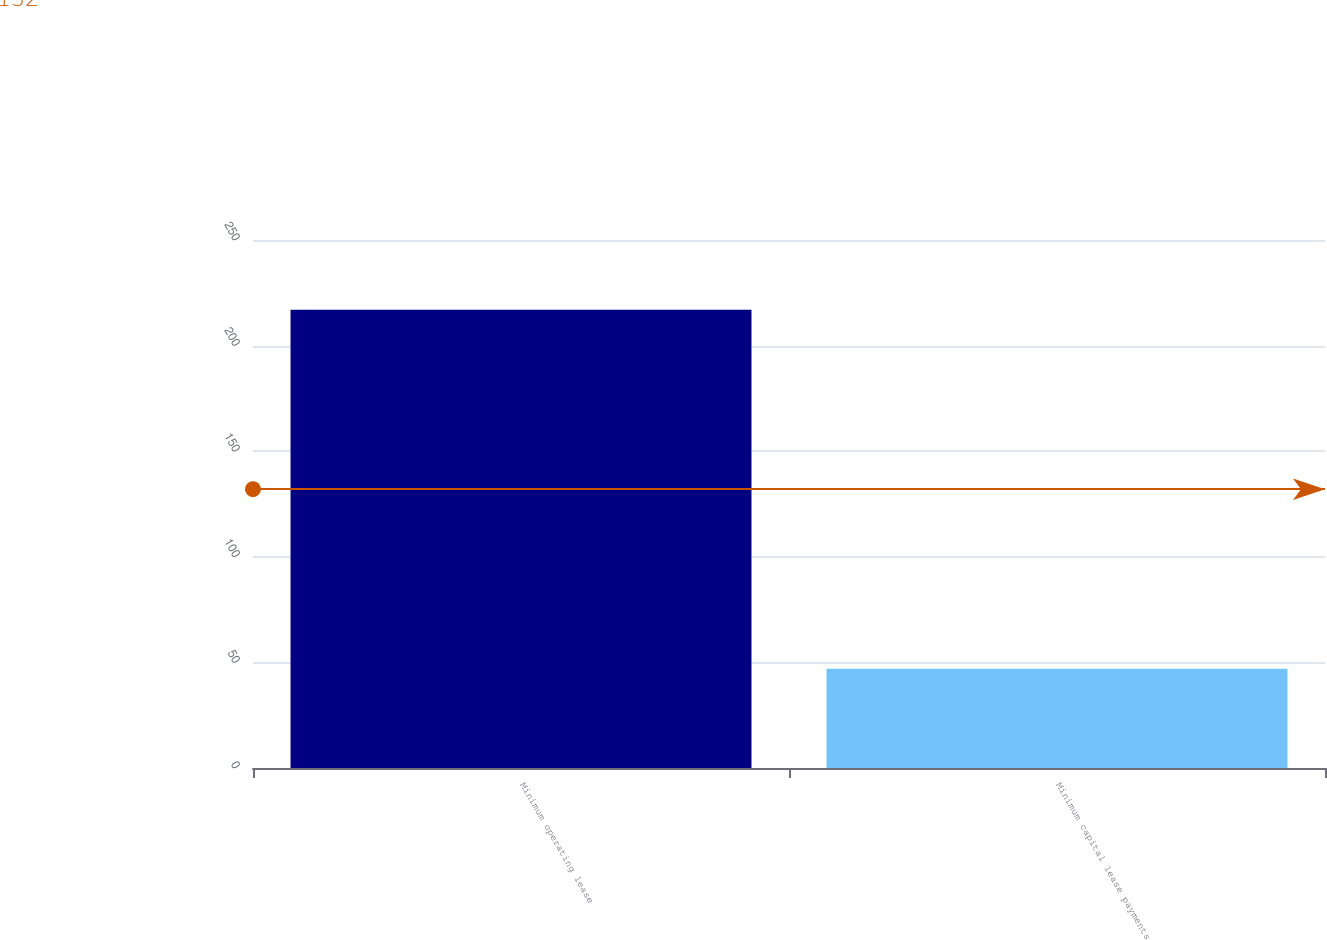<chart> <loc_0><loc_0><loc_500><loc_500><bar_chart><fcel>Minimum operating lease<fcel>Minimum capital lease payments<nl><fcel>217<fcel>47<nl></chart> 